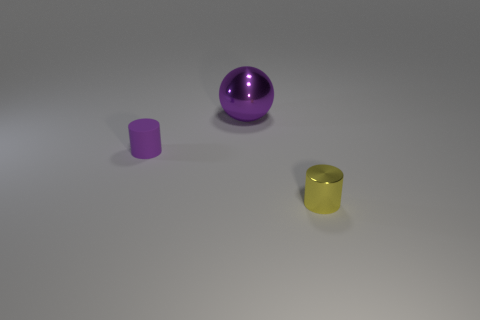Is there any other thing that has the same size as the purple sphere?
Provide a succinct answer. No. Are there any other things that are made of the same material as the purple cylinder?
Provide a short and direct response. No. Are there any purple matte cylinders that have the same size as the yellow metal object?
Ensure brevity in your answer.  Yes. What number of other things are made of the same material as the purple ball?
Make the answer very short. 1. There is a object that is both to the left of the yellow cylinder and in front of the big shiny thing; what color is it?
Keep it short and to the point. Purple. Is the material of the small object that is behind the yellow shiny object the same as the cylinder to the right of the purple metallic object?
Your response must be concise. No. There is a cylinder left of the yellow cylinder; is it the same size as the purple shiny object?
Make the answer very short. No. There is a small shiny thing; does it have the same color as the cylinder that is behind the yellow cylinder?
Make the answer very short. No. There is another object that is the same color as the large thing; what shape is it?
Provide a short and direct response. Cylinder. What shape is the big purple shiny object?
Keep it short and to the point. Sphere. 